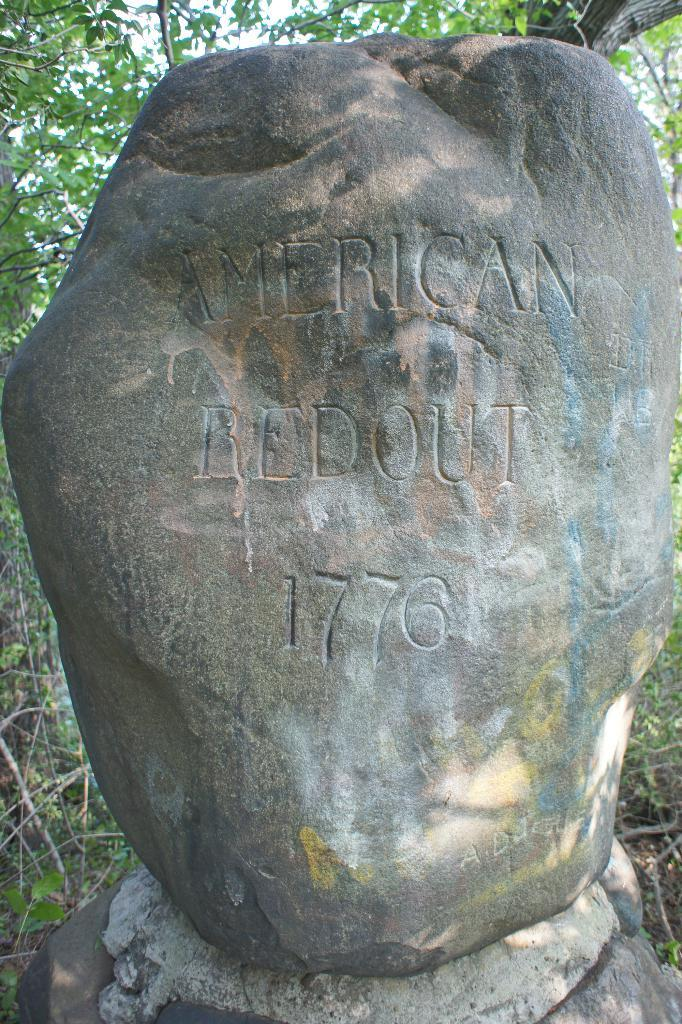What is the main subject of the image? The main subject of the image is a rock. What is unique about the rock in the image? Text is written on the rock. How many pins can be seen attached to the rock in the image? There are no pins visible in the image; it only features a rock with text written on it. 